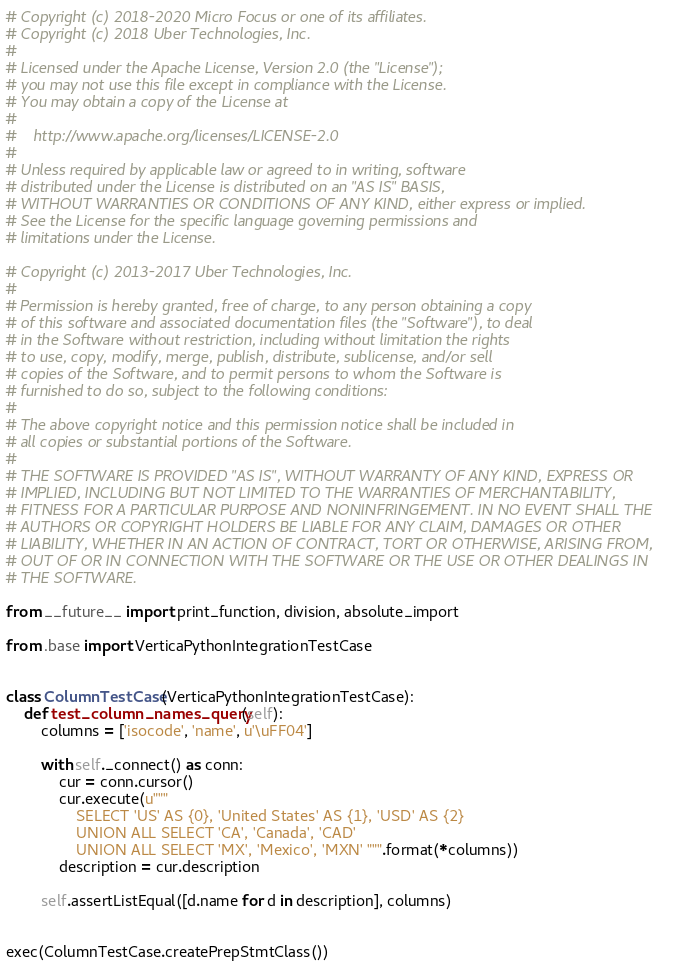<code> <loc_0><loc_0><loc_500><loc_500><_Python_># Copyright (c) 2018-2020 Micro Focus or one of its affiliates.
# Copyright (c) 2018 Uber Technologies, Inc.
#
# Licensed under the Apache License, Version 2.0 (the "License");
# you may not use this file except in compliance with the License.
# You may obtain a copy of the License at
#
#    http://www.apache.org/licenses/LICENSE-2.0
#
# Unless required by applicable law or agreed to in writing, software
# distributed under the License is distributed on an "AS IS" BASIS,
# WITHOUT WARRANTIES OR CONDITIONS OF ANY KIND, either express or implied.
# See the License for the specific language governing permissions and
# limitations under the License.

# Copyright (c) 2013-2017 Uber Technologies, Inc.
#
# Permission is hereby granted, free of charge, to any person obtaining a copy
# of this software and associated documentation files (the "Software"), to deal
# in the Software without restriction, including without limitation the rights
# to use, copy, modify, merge, publish, distribute, sublicense, and/or sell
# copies of the Software, and to permit persons to whom the Software is
# furnished to do so, subject to the following conditions:
#
# The above copyright notice and this permission notice shall be included in
# all copies or substantial portions of the Software.
#
# THE SOFTWARE IS PROVIDED "AS IS", WITHOUT WARRANTY OF ANY KIND, EXPRESS OR
# IMPLIED, INCLUDING BUT NOT LIMITED TO THE WARRANTIES OF MERCHANTABILITY,
# FITNESS FOR A PARTICULAR PURPOSE AND NONINFRINGEMENT. IN NO EVENT SHALL THE
# AUTHORS OR COPYRIGHT HOLDERS BE LIABLE FOR ANY CLAIM, DAMAGES OR OTHER
# LIABILITY, WHETHER IN AN ACTION OF CONTRACT, TORT OR OTHERWISE, ARISING FROM,
# OUT OF OR IN CONNECTION WITH THE SOFTWARE OR THE USE OR OTHER DEALINGS IN
# THE SOFTWARE.

from __future__ import print_function, division, absolute_import

from .base import VerticaPythonIntegrationTestCase


class ColumnTestCase(VerticaPythonIntegrationTestCase):
    def test_column_names_query(self):
        columns = ['isocode', 'name', u'\uFF04']

        with self._connect() as conn:
            cur = conn.cursor()
            cur.execute(u"""
                SELECT 'US' AS {0}, 'United States' AS {1}, 'USD' AS {2}
                UNION ALL SELECT 'CA', 'Canada', 'CAD'
                UNION ALL SELECT 'MX', 'Mexico', 'MXN' """.format(*columns))
            description = cur.description

        self.assertListEqual([d.name for d in description], columns)


exec(ColumnTestCase.createPrepStmtClass())
</code> 